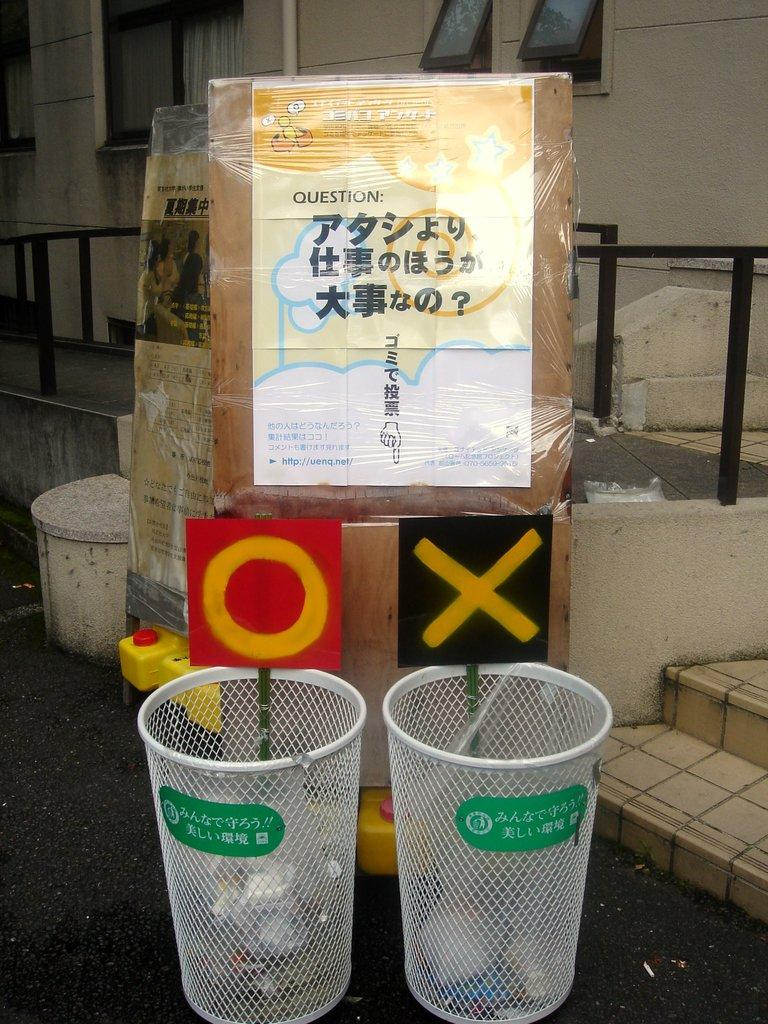<image>
Present a compact description of the photo's key features. A sign with http://uenq.net/ at the bottom sits above two trash cans. 